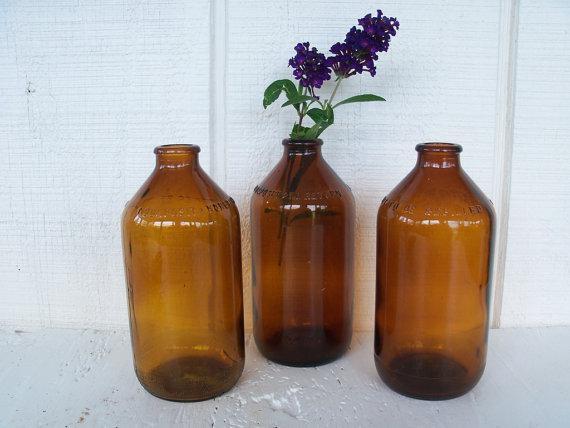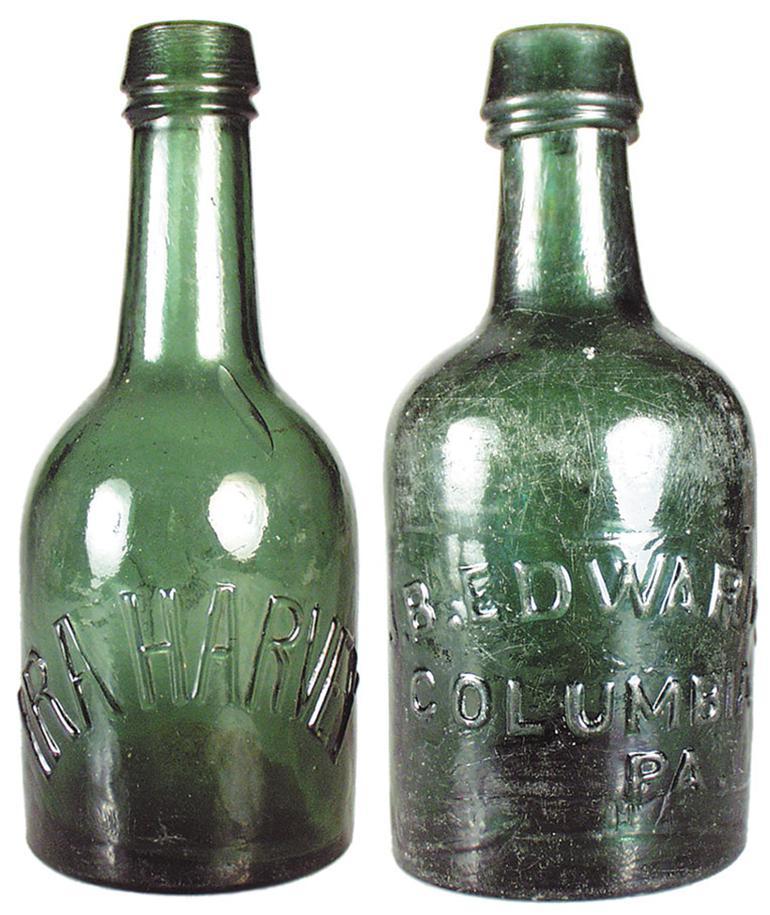The first image is the image on the left, the second image is the image on the right. Assess this claim about the two images: "In one image, three brown bottles have wide, squat bodies, and a small, rimmed top edge.". Correct or not? Answer yes or no. Yes. 